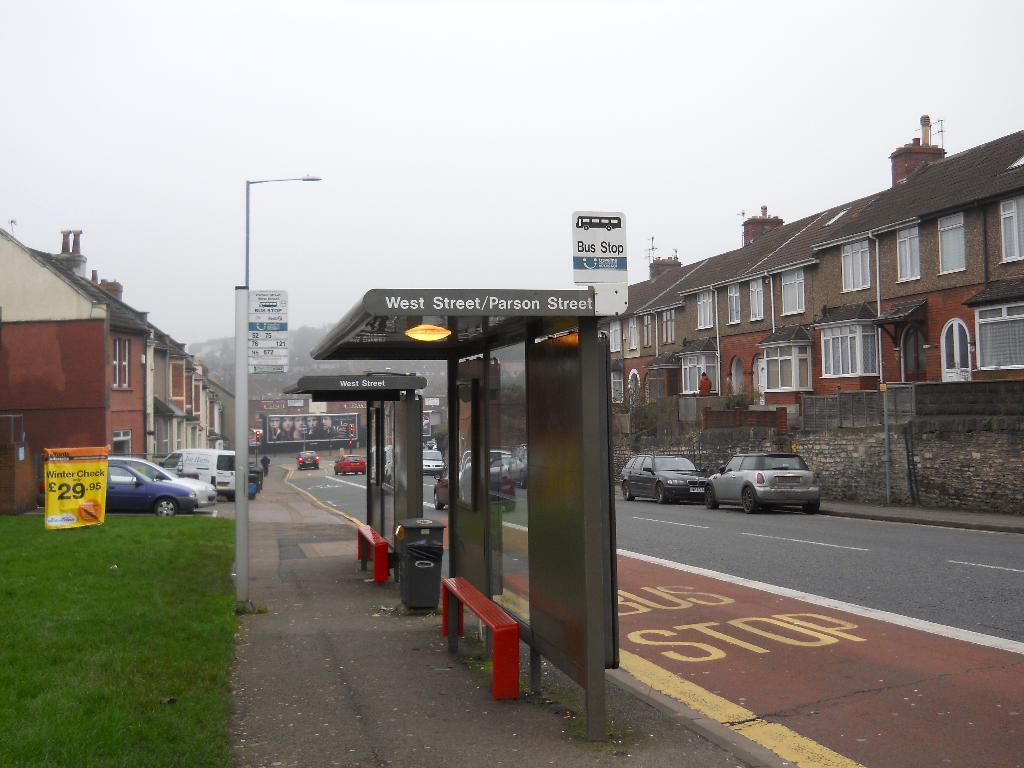What street is this on?
Offer a very short reply. West street/parson street. How much is a winter check?
Offer a terse response. 29.95. 